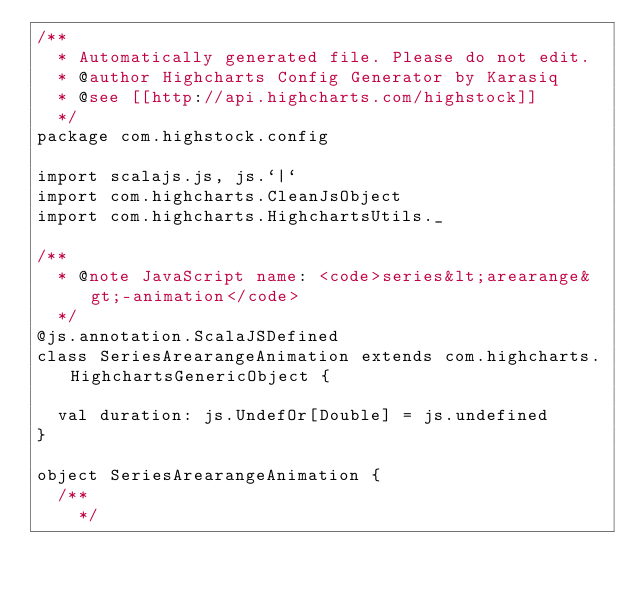Convert code to text. <code><loc_0><loc_0><loc_500><loc_500><_Scala_>/**
  * Automatically generated file. Please do not edit.
  * @author Highcharts Config Generator by Karasiq
  * @see [[http://api.highcharts.com/highstock]]
  */
package com.highstock.config

import scalajs.js, js.`|`
import com.highcharts.CleanJsObject
import com.highcharts.HighchartsUtils._

/**
  * @note JavaScript name: <code>series&lt;arearange&gt;-animation</code>
  */
@js.annotation.ScalaJSDefined
class SeriesArearangeAnimation extends com.highcharts.HighchartsGenericObject {

  val duration: js.UndefOr[Double] = js.undefined
}

object SeriesArearangeAnimation {
  /**
    */</code> 